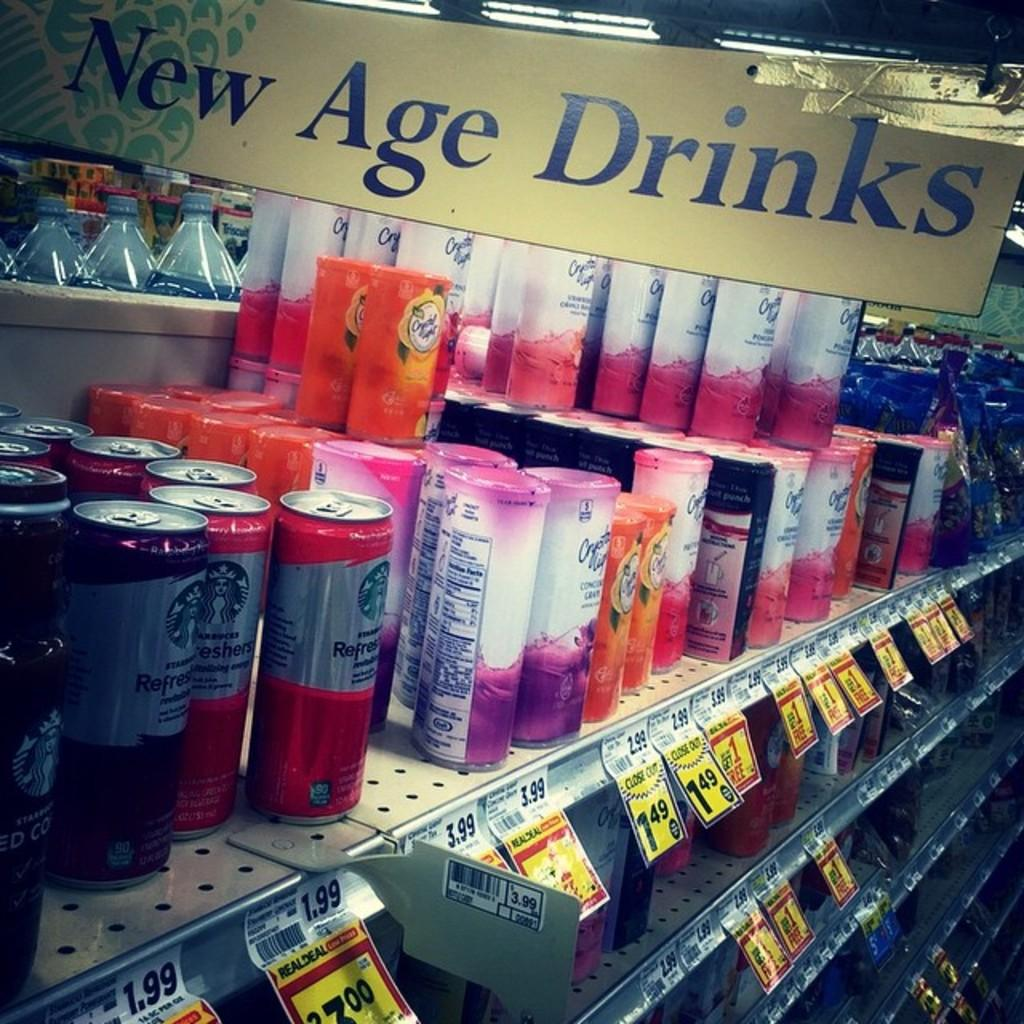<image>
Relay a brief, clear account of the picture shown. Various beverages are on shelves under a sign advertising New Age Drinks. 